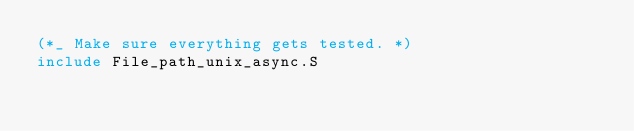<code> <loc_0><loc_0><loc_500><loc_500><_OCaml_>(*_ Make sure everything gets tested. *)
include File_path_unix_async.S
</code> 